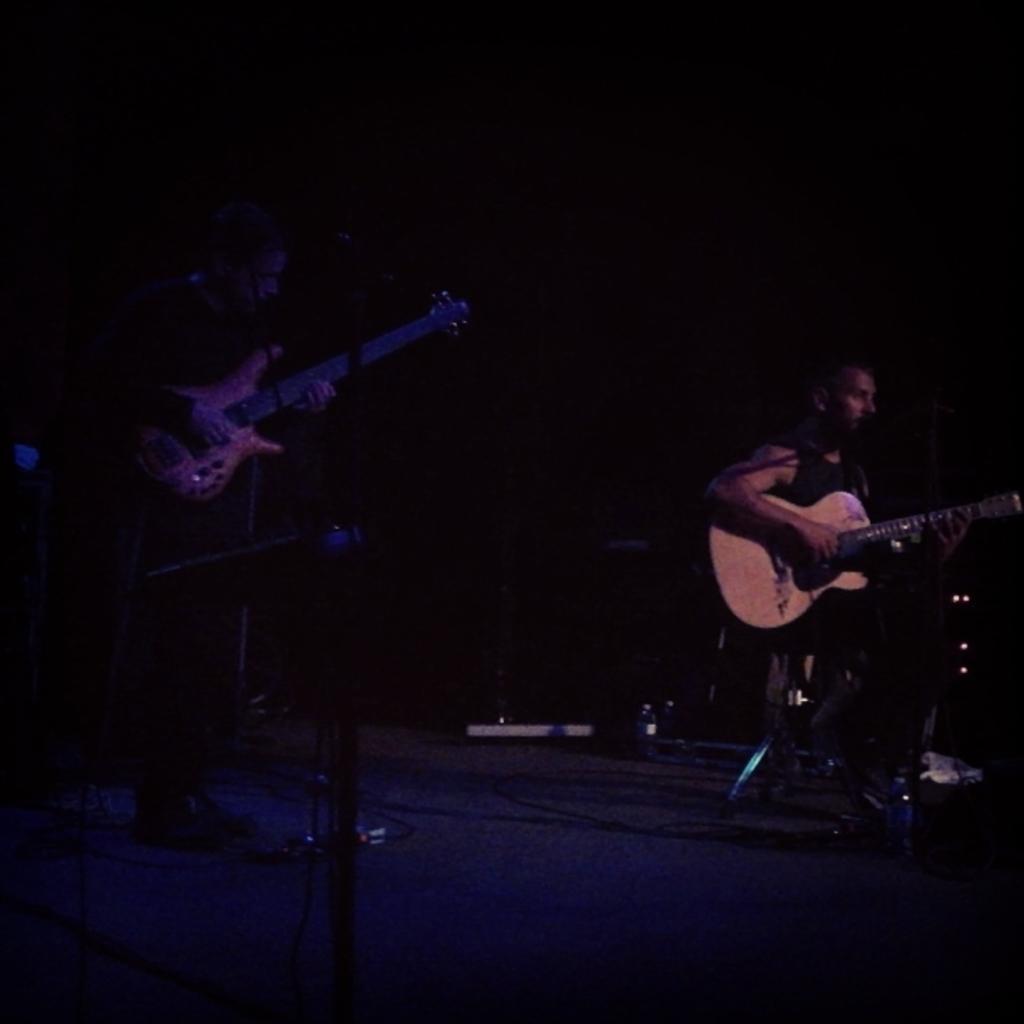How would you summarize this image in a sentence or two? In the image there are two men playing guitar and singing on mic, this looks like a concert. 